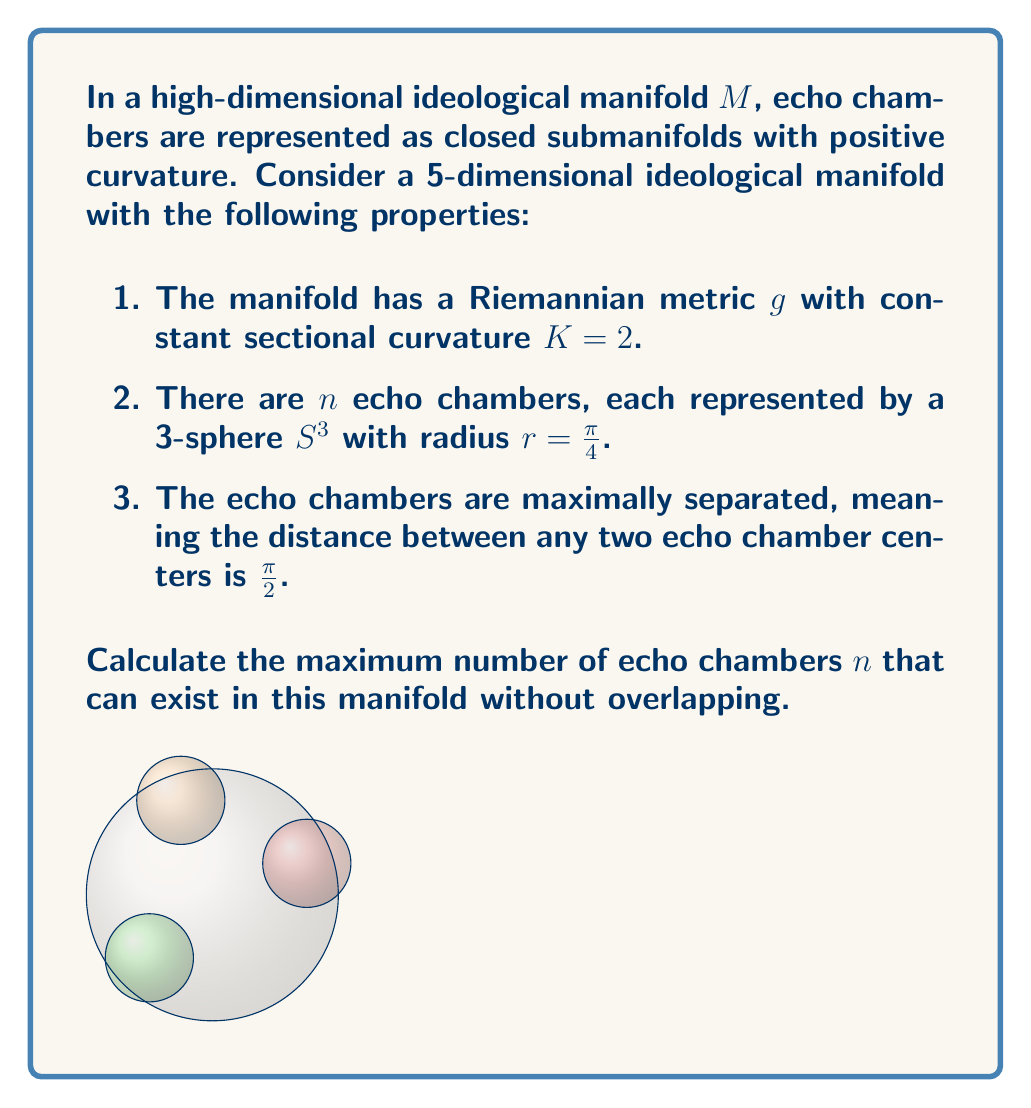Give your solution to this math problem. Let's approach this step-by-step:

1) First, we need to understand the geometry of our manifold. It's a 5-dimensional space with constant sectional curvature $K = 2$. This means it's a scaled version of a 5-sphere $S^5$.

2) The radius $R$ of this $S^5$ can be calculated using the formula:

   $K = \frac{1}{R^2}$

   $2 = \frac{1}{R^2}$
   $R = \frac{1}{\sqrt{2}}$

3) Now, we're looking for the maximum number of 3-spheres with radius $r = \frac{\pi}{4}$ that can fit on this $S^5$ such that their centers are separated by a distance of $\frac{\pi}{2}$.

4) This is equivalent to finding the kissing number in a curved space. The centers of these 3-spheres form a spherical code on $S^5$.

5) In a curved space, we need to use the spherical distance formula:

   $\cos(\frac{d}{R}) = \cos(\frac{\pi}{2}) = 0$

   where $d$ is the Euclidean distance between points in the ambient space.

6) The problem is now equivalent to finding the maximum number of points on $S^5$ with angular separation $\frac{\pi}{2}$.

7) This is known as the orthoplex code, and for $S^5$, the maximum number of such points is:

   $n = 2(5+1) = 12$

8) We need to verify that these 3-spheres don't overlap. The distance between the surfaces of two adjacent 3-spheres should be positive:

   $\frac{\pi}{2} - 2\frac{\pi}{4} = 0$

   They just touch, so our solution is valid.
Answer: 12 